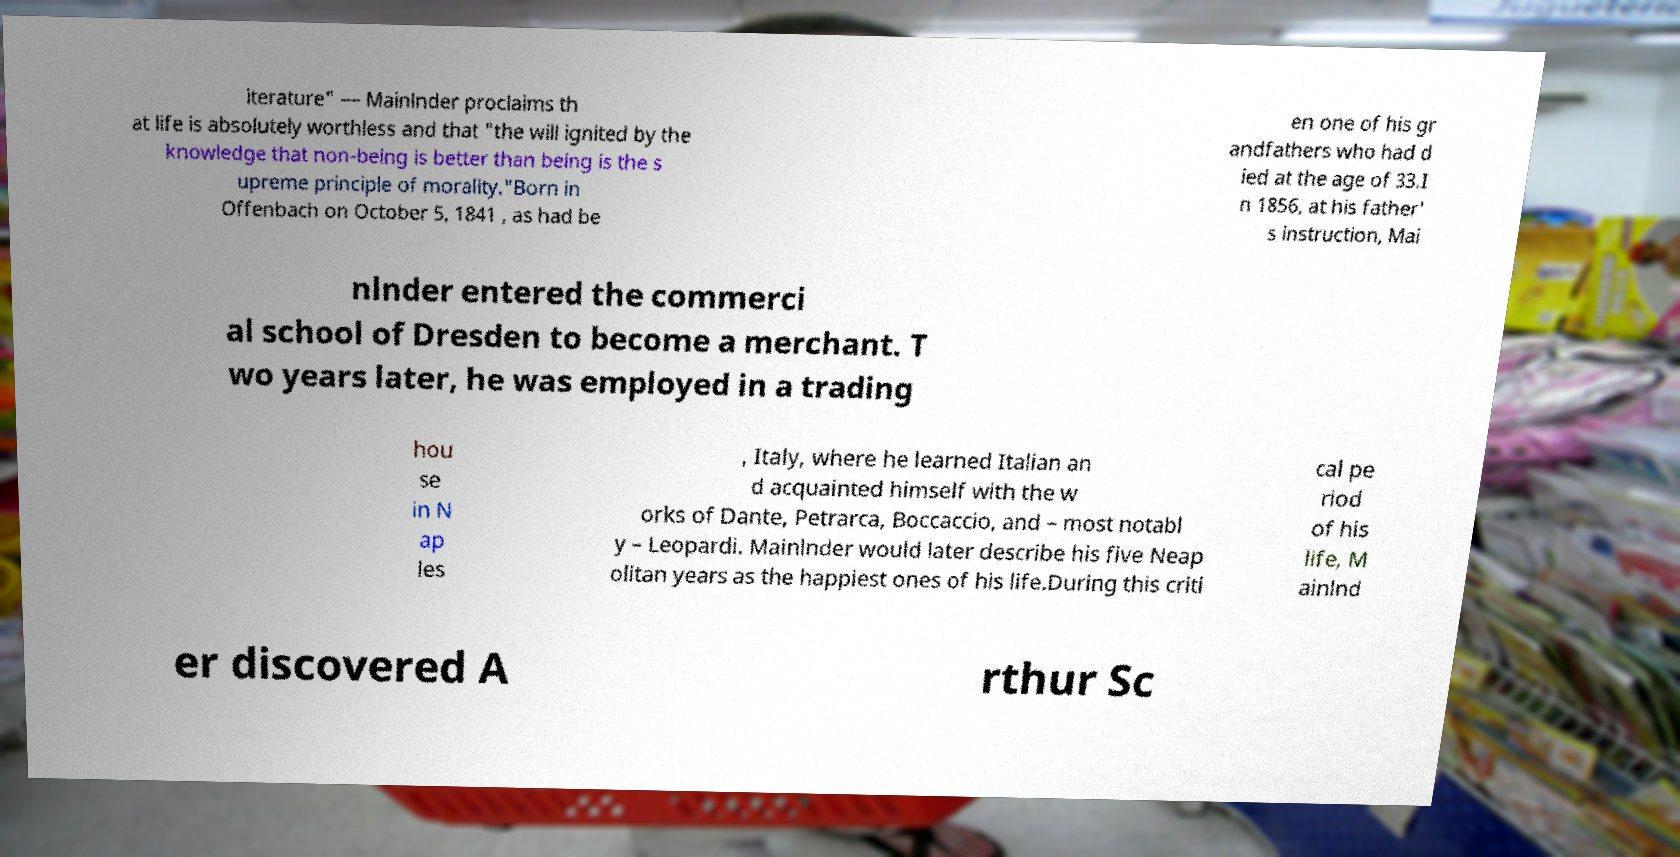For documentation purposes, I need the text within this image transcribed. Could you provide that? iterature" — Mainlnder proclaims th at life is absolutely worthless and that "the will ignited by the knowledge that non-being is better than being is the s upreme principle of morality."Born in Offenbach on October 5, 1841 , as had be en one of his gr andfathers who had d ied at the age of 33.I n 1856, at his father' s instruction, Mai nlnder entered the commerci al school of Dresden to become a merchant. T wo years later, he was employed in a trading hou se in N ap les , Italy, where he learned Italian an d acquainted himself with the w orks of Dante, Petrarca, Boccaccio, and – most notabl y – Leopardi. Mainlnder would later describe his five Neap olitan years as the happiest ones of his life.During this criti cal pe riod of his life, M ainlnd er discovered A rthur Sc 